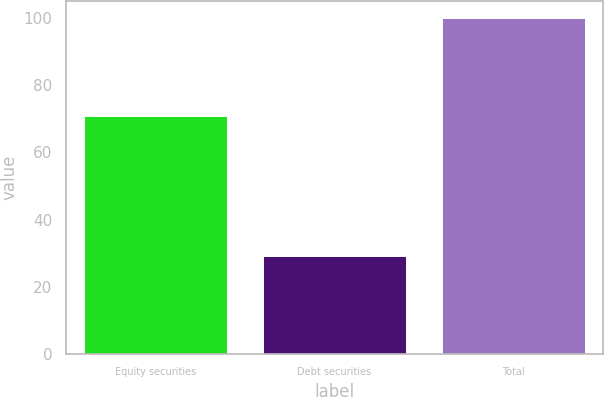Convert chart. <chart><loc_0><loc_0><loc_500><loc_500><bar_chart><fcel>Equity securities<fcel>Debt securities<fcel>Total<nl><fcel>70.9<fcel>29.1<fcel>100<nl></chart> 